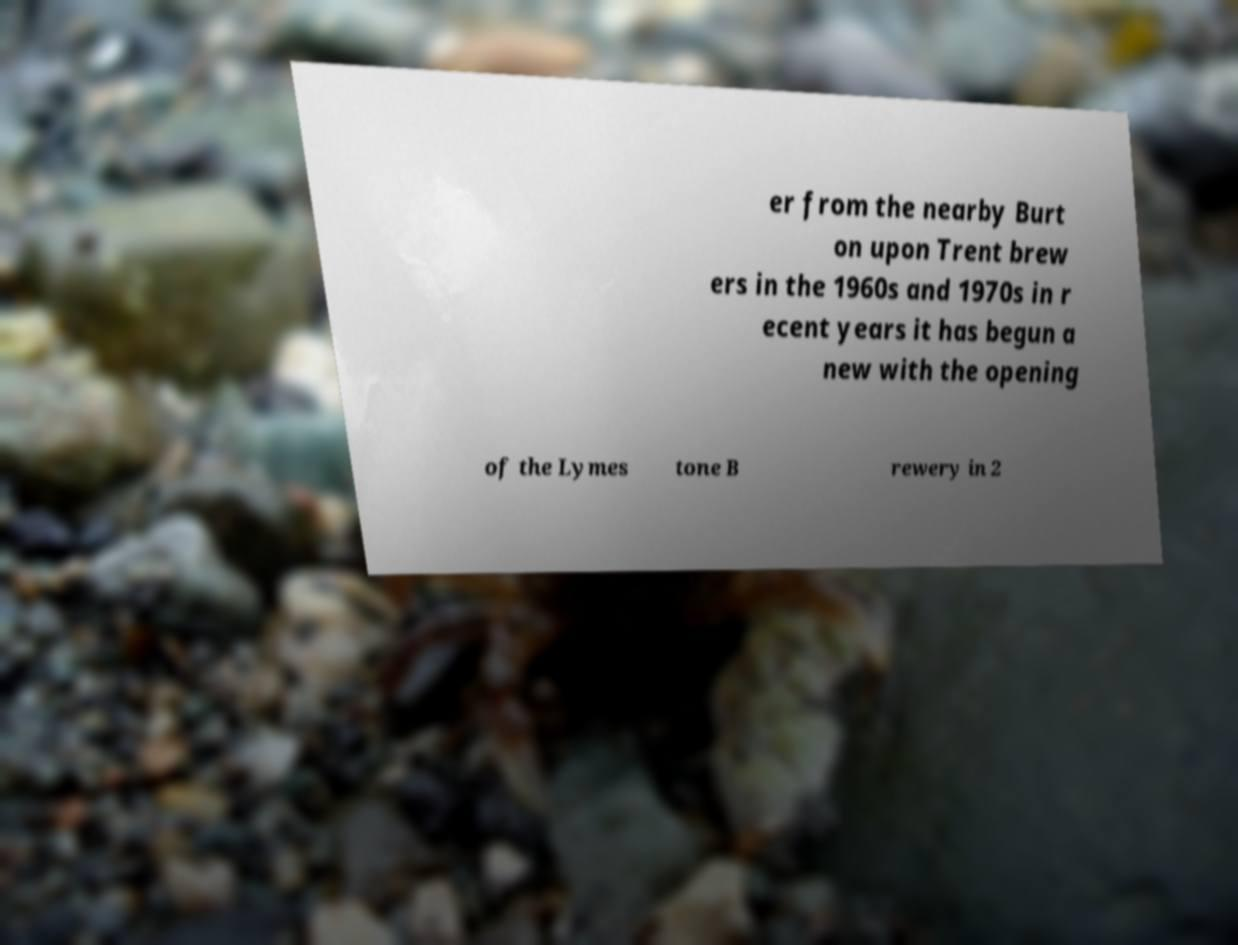Can you accurately transcribe the text from the provided image for me? er from the nearby Burt on upon Trent brew ers in the 1960s and 1970s in r ecent years it has begun a new with the opening of the Lymes tone B rewery in 2 